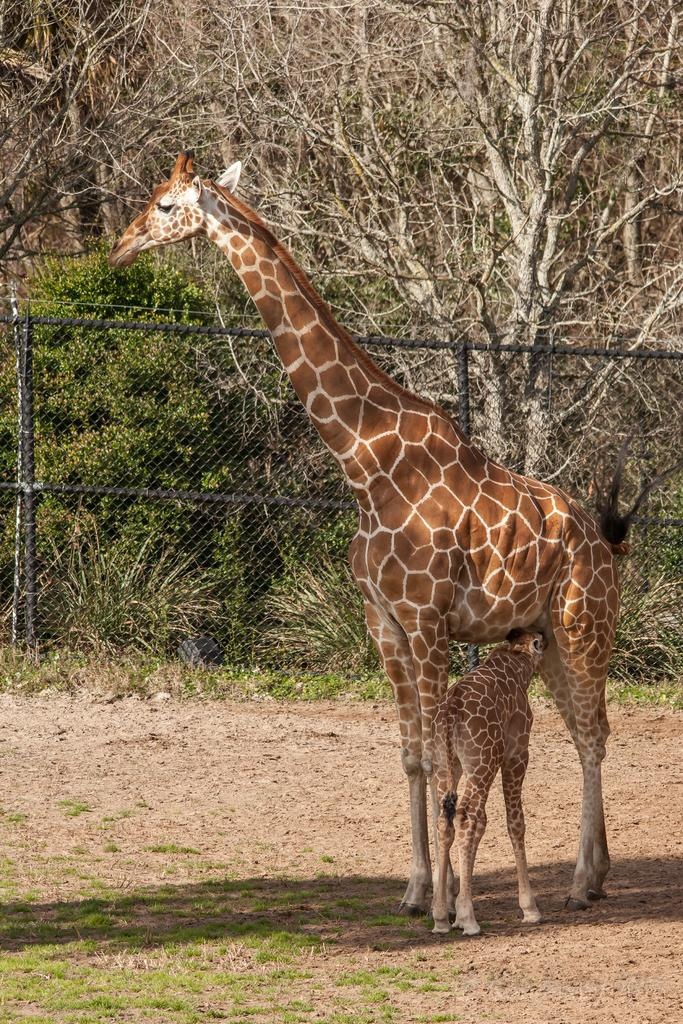What animal is on the ground in the image? There is a giraffe on the ground in the image. What type of vegetation is visible in the image? There is grass visible in the image. What type of barrier is present in the image? There is a metal fence in the image. What type of natural feature is present in the image? There is a group of trees in the image. What type of sign can be seen hanging from the giraffe's neck in the image? There is no sign present in the image; the giraffe is not holding or wearing any sign. 